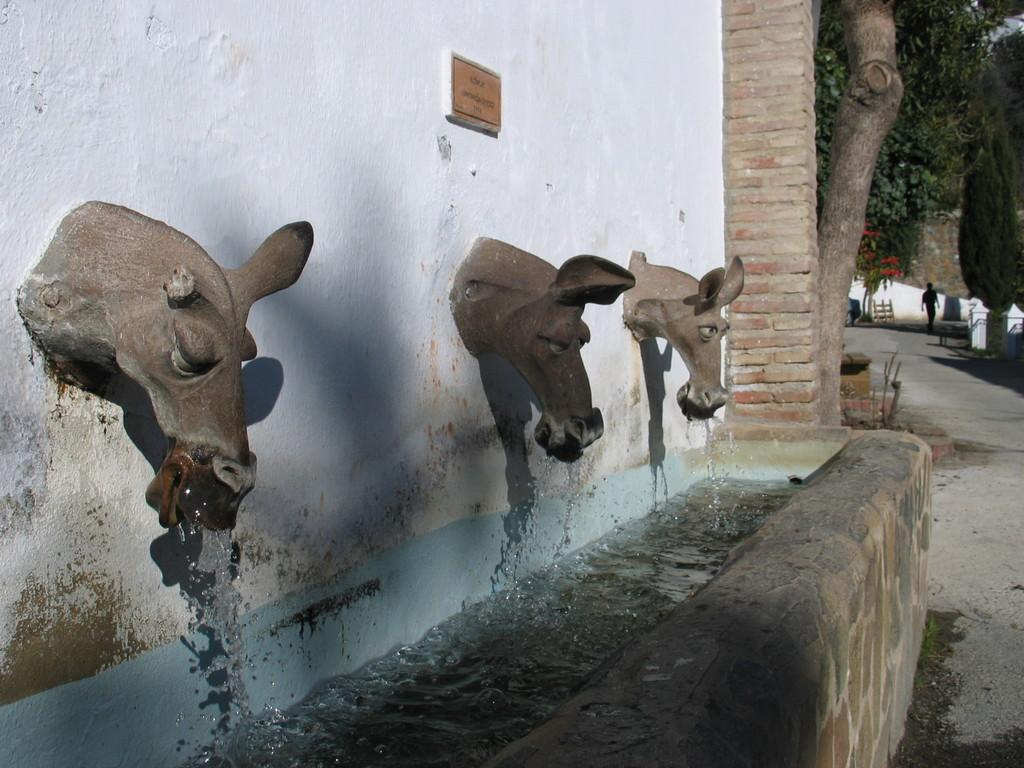What is the color of the wall in the image? The wall in the image is white. What can be seen on the wall in the image? There are statues on the wall in the image. What type of vegetation is present in the image? There are trees in the image. What is the person in the image doing? There is a person walking on a road in the image. What type of grip does the bat have in the image? There is no bat present in the image. 